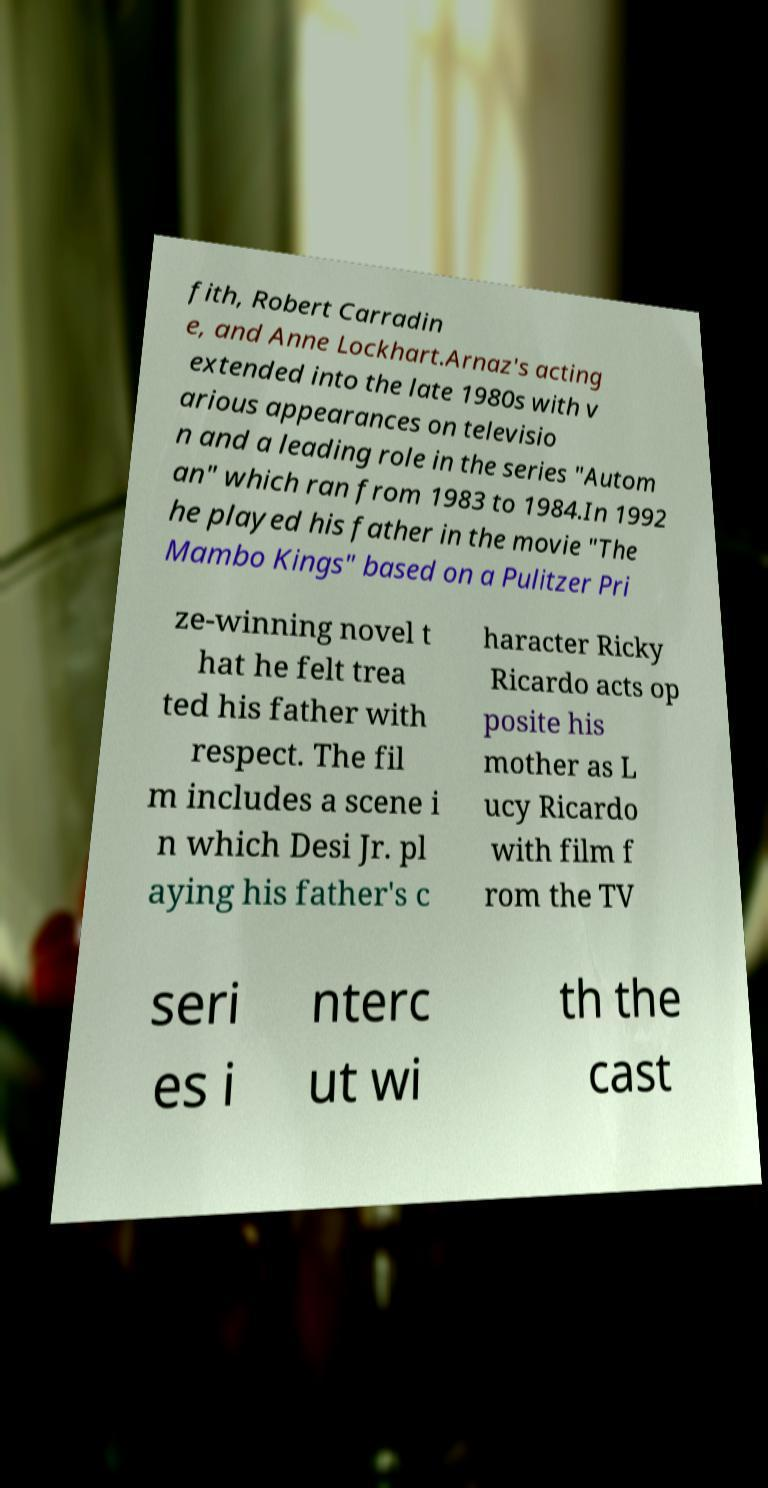I need the written content from this picture converted into text. Can you do that? fith, Robert Carradin e, and Anne Lockhart.Arnaz's acting extended into the late 1980s with v arious appearances on televisio n and a leading role in the series "Autom an" which ran from 1983 to 1984.In 1992 he played his father in the movie "The Mambo Kings" based on a Pulitzer Pri ze-winning novel t hat he felt trea ted his father with respect. The fil m includes a scene i n which Desi Jr. pl aying his father's c haracter Ricky Ricardo acts op posite his mother as L ucy Ricardo with film f rom the TV seri es i nterc ut wi th the cast 